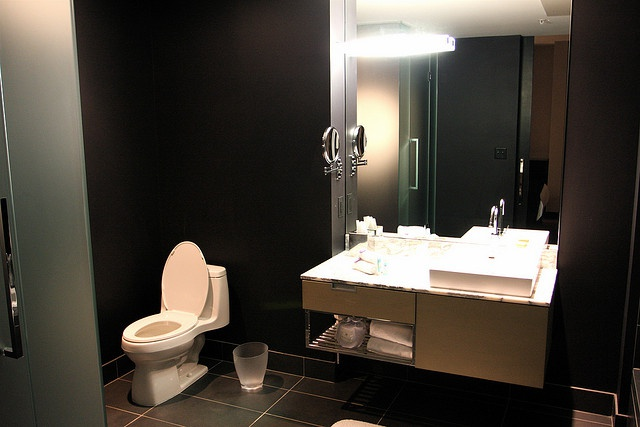Describe the objects in this image and their specific colors. I can see toilet in tan and beige tones and sink in tan and white tones in this image. 